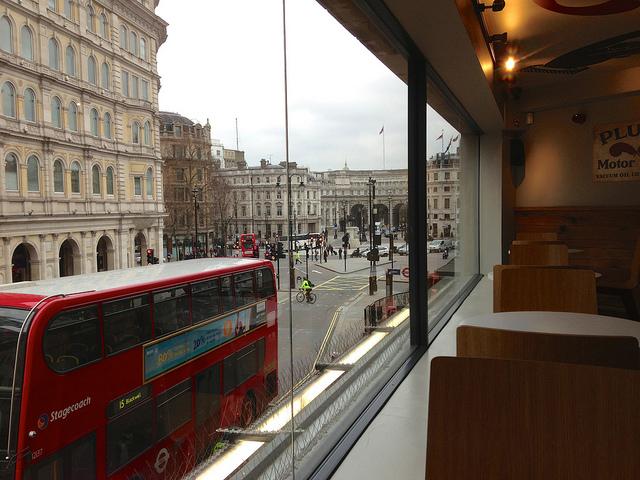Is the bus crowded?
Be succinct. No. Is this night time?
Quick response, please. No. Where is this photo taken?
Quick response, please. London. What type of transportation is this?
Give a very brief answer. Bus. What mode of transportation is being provided?
Write a very short answer. Bus. Are people seated at the tables in the picture?
Be succinct. No. Is it rush hour?
Concise answer only. No. What type of vehicle is this?
Be succinct. Bus. 